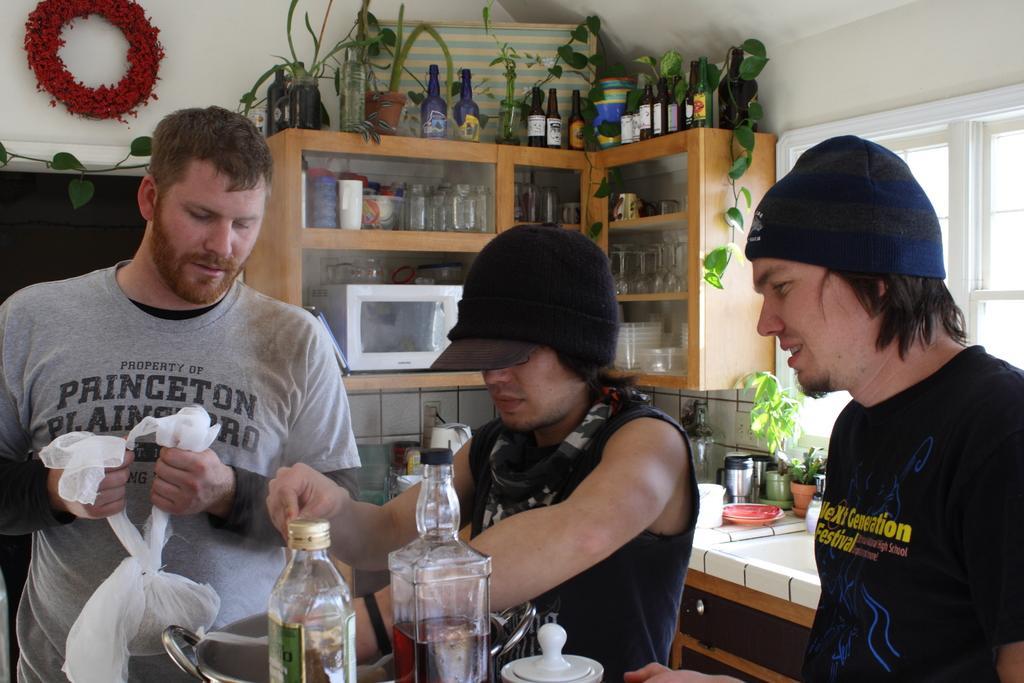Please provide a concise description of this image. In this image there is a person holding a paper bag in his hand, beside the person there are two other people, in front of them there are bottles and some other objects, behind them on the kitchen platform, there are some utensils, above the kitchen platform on the cupboards there is a microwave oven, glasses and some other objects, on top of the cupboards there are bottles and leaves, beside the cupboard there is a glass window, on top of the wall there is a flower bouquet. 